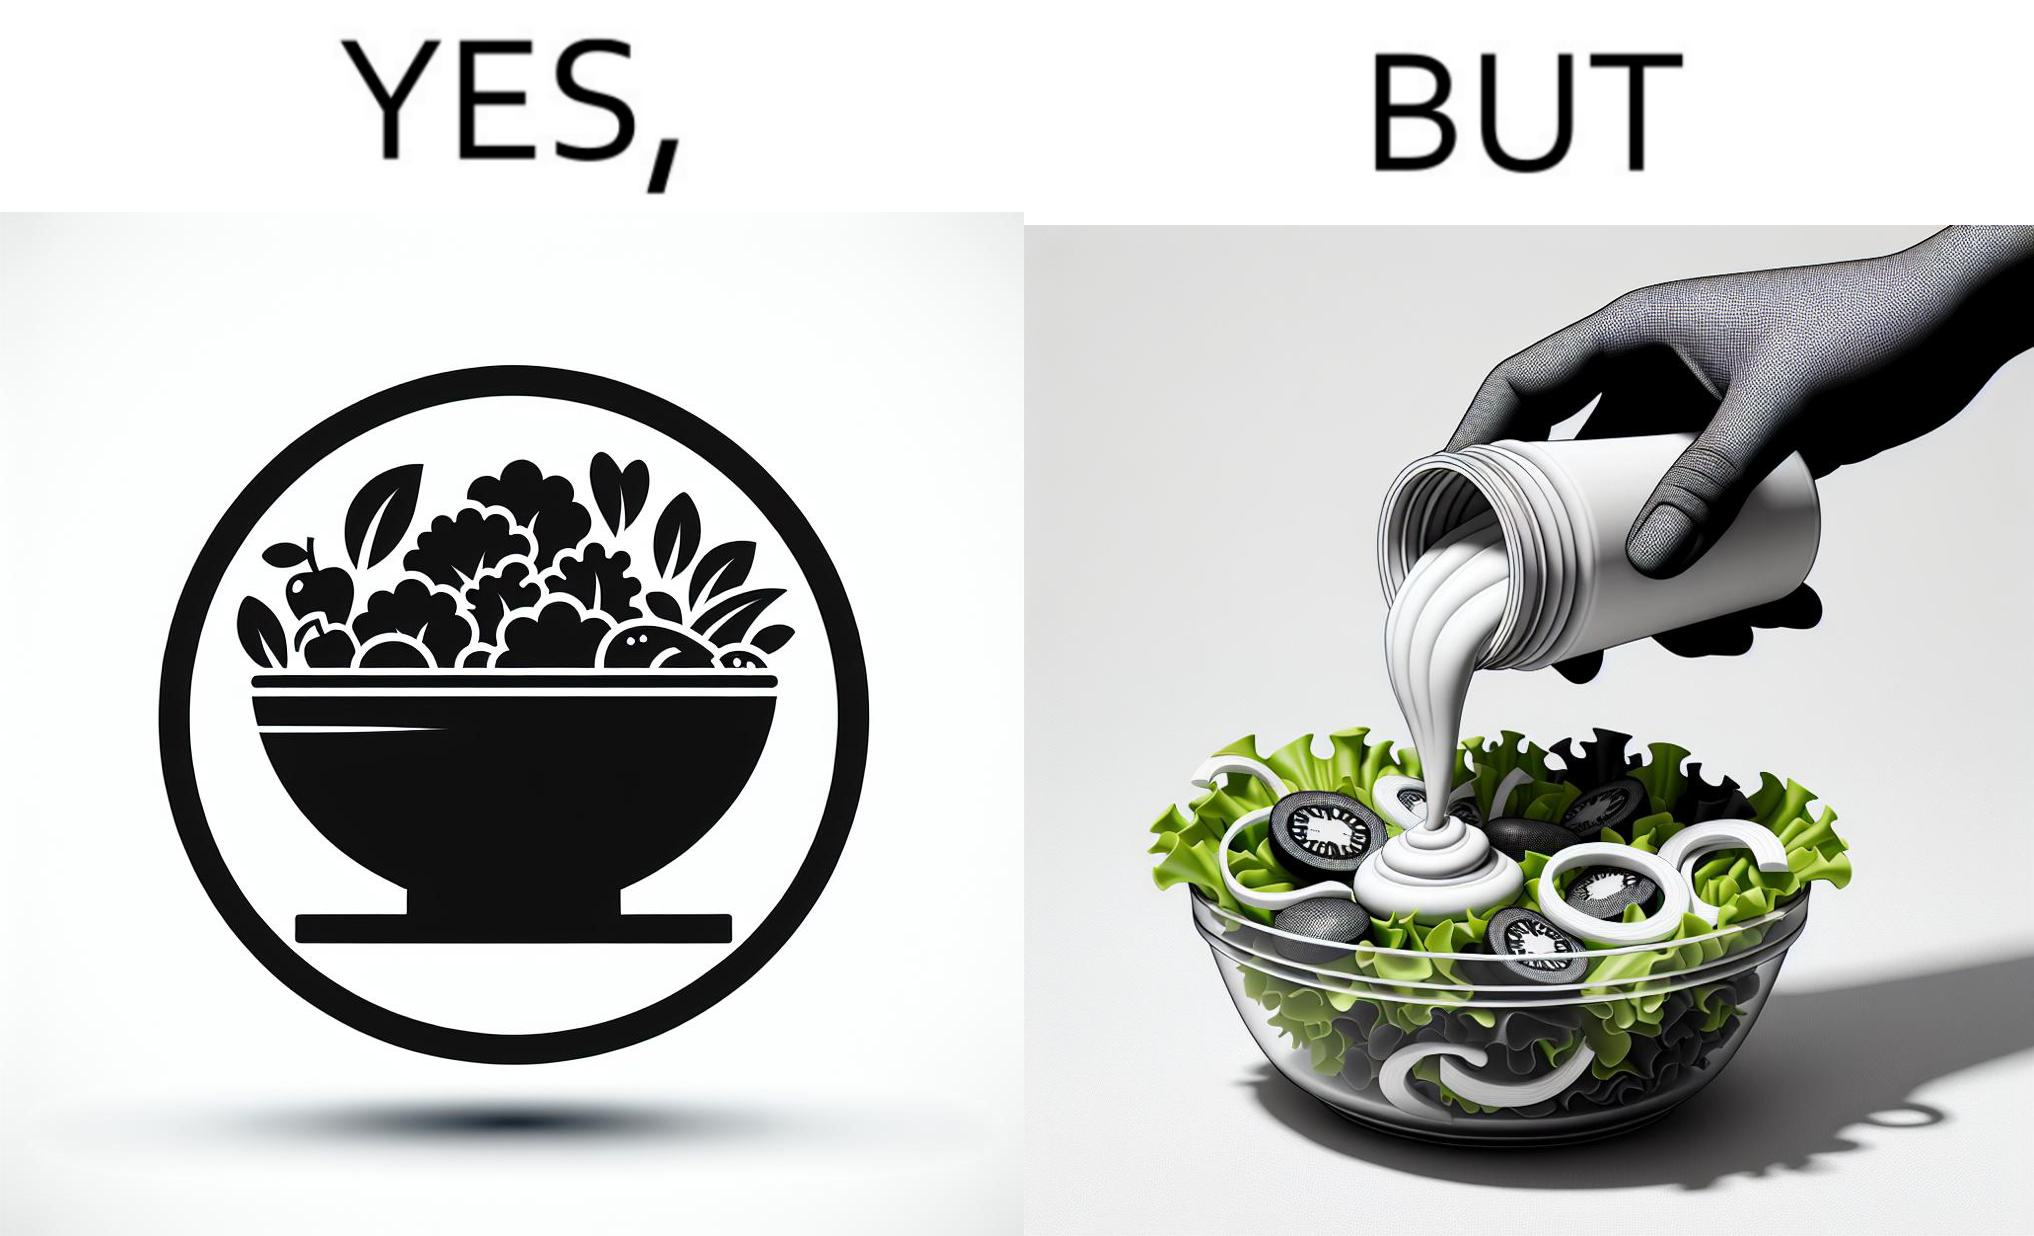Is there satirical content in this image? Yes, this image is satirical. 